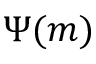<formula> <loc_0><loc_0><loc_500><loc_500>\Psi ( m )</formula> 